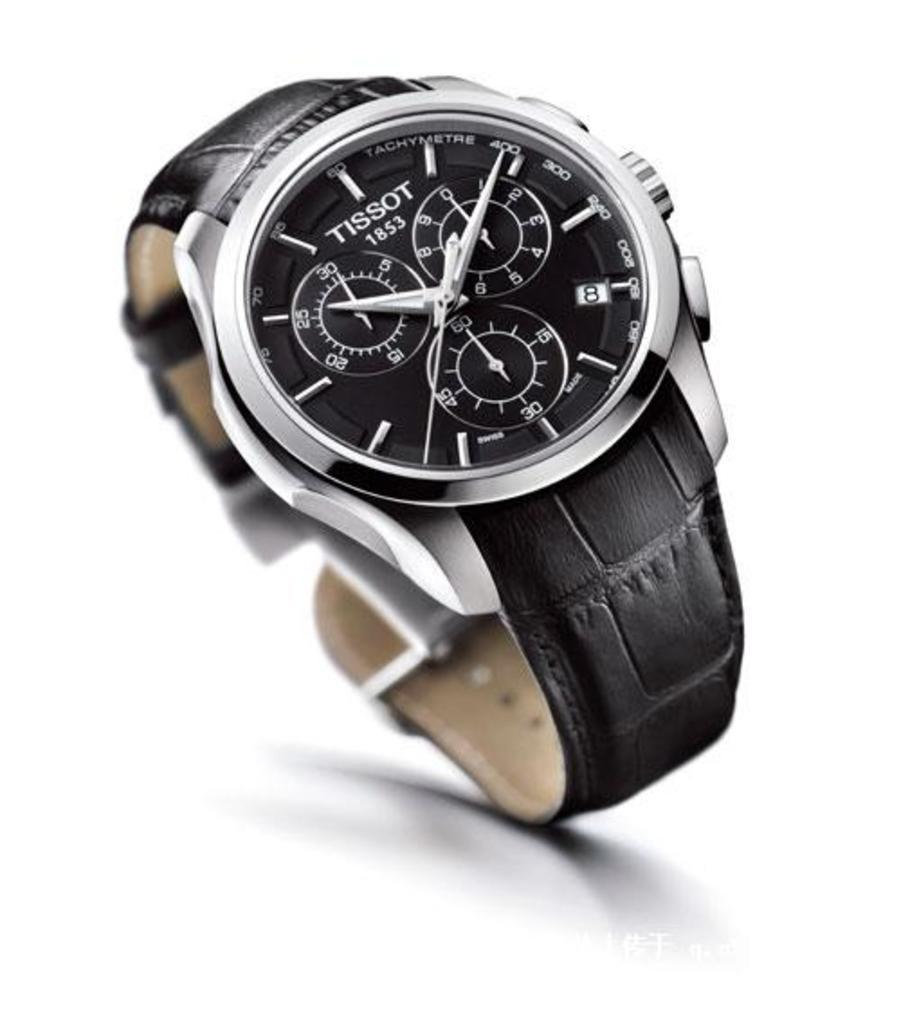Provide a one-sentence caption for the provided image. A Tissot watch with a black band and a black face. 